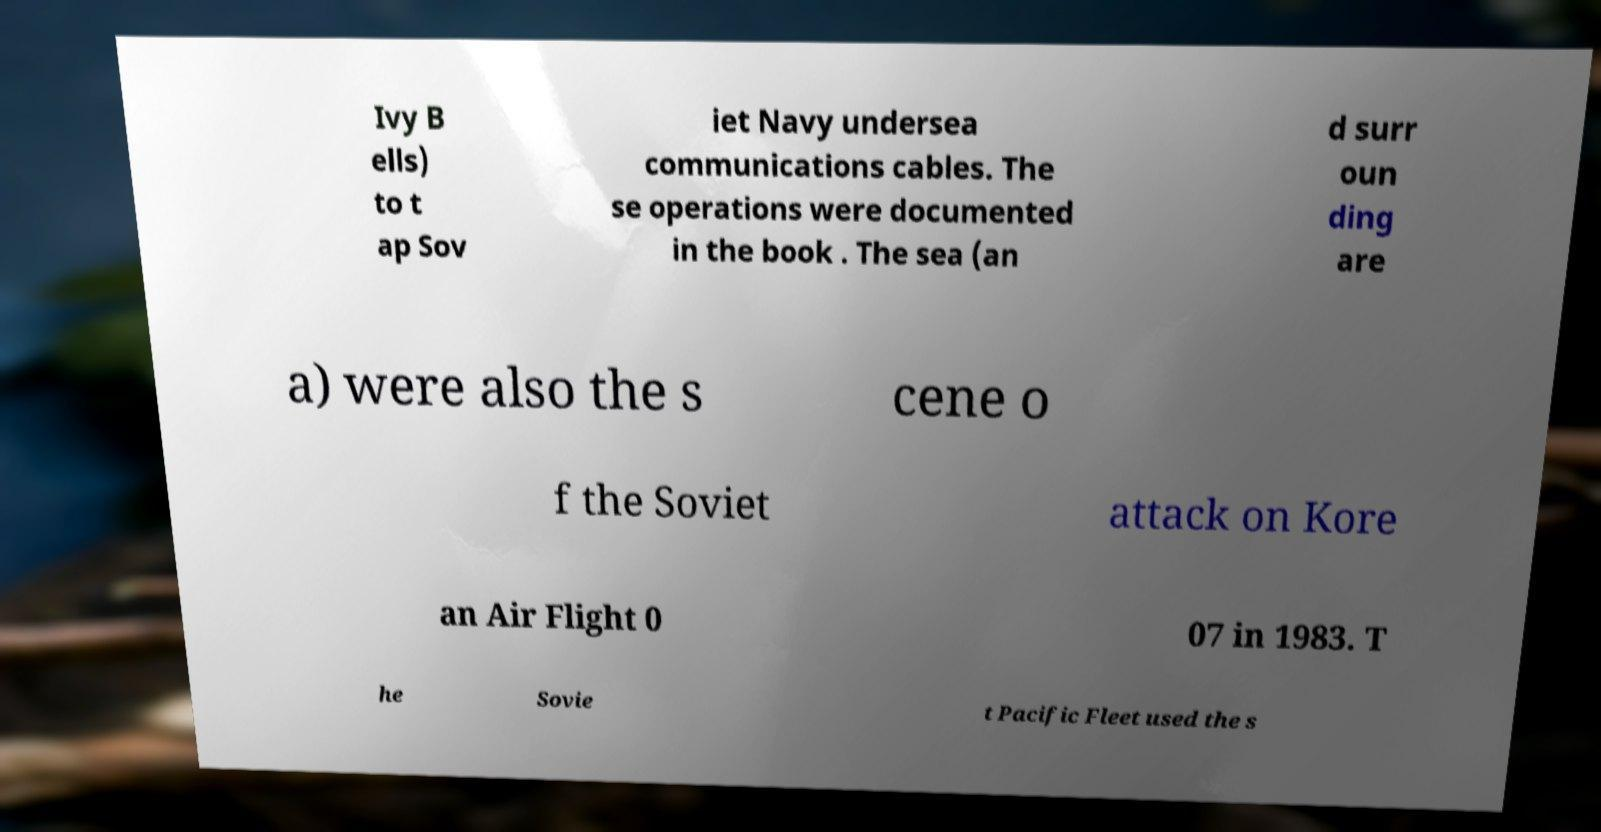Please read and relay the text visible in this image. What does it say? Ivy B ells) to t ap Sov iet Navy undersea communications cables. The se operations were documented in the book . The sea (an d surr oun ding are a) were also the s cene o f the Soviet attack on Kore an Air Flight 0 07 in 1983. T he Sovie t Pacific Fleet used the s 